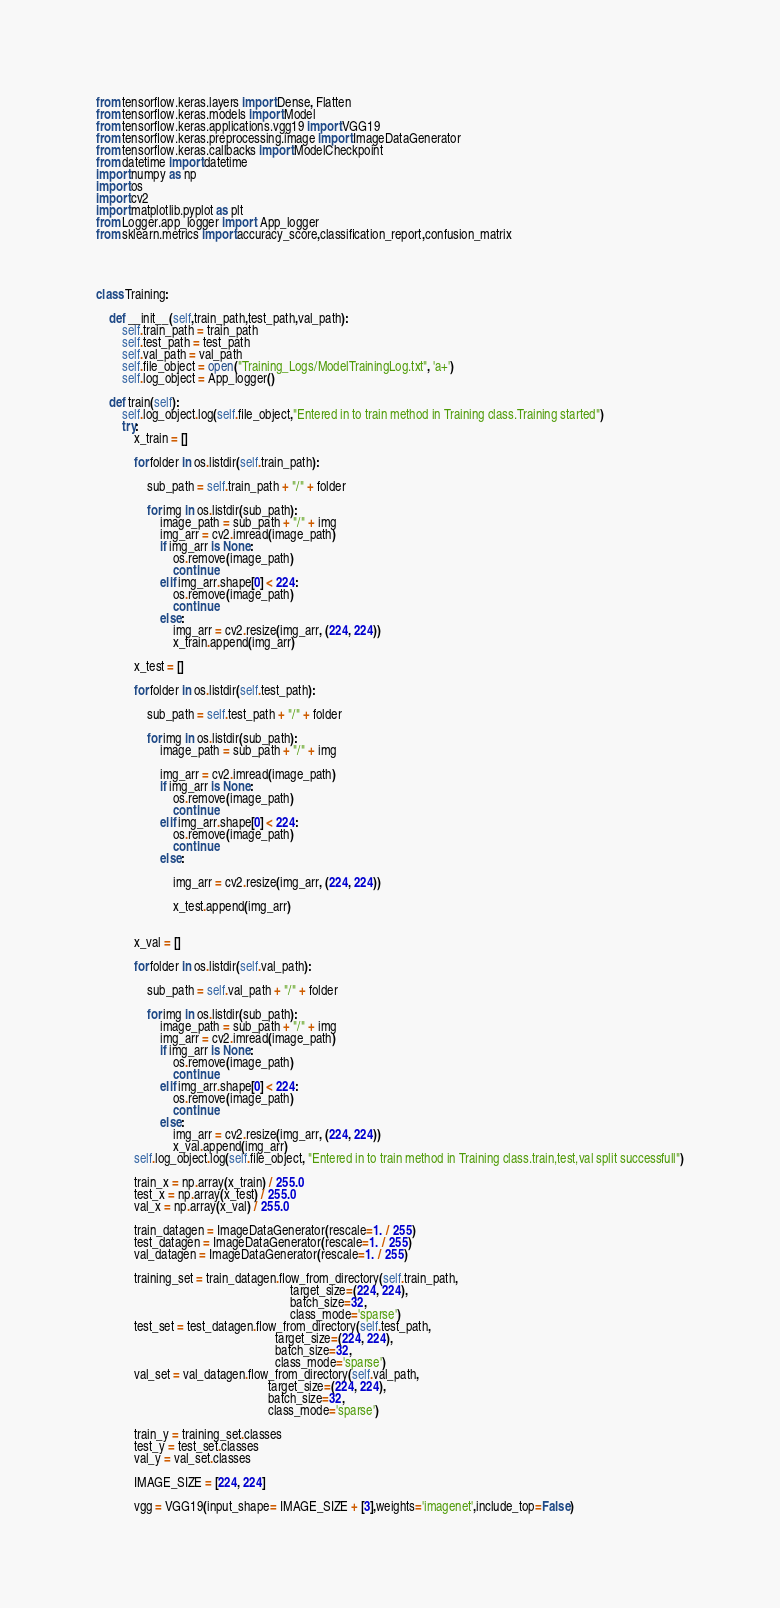Convert code to text. <code><loc_0><loc_0><loc_500><loc_500><_Python_>from tensorflow.keras.layers import Dense, Flatten
from tensorflow.keras.models import Model
from tensorflow.keras.applications.vgg19 import VGG19
from tensorflow.keras.preprocessing.image import ImageDataGenerator
from tensorflow.keras.callbacks import ModelCheckpoint
from datetime import datetime
import numpy as np
import os
import cv2
import matplotlib.pyplot as plt
from Logger.app_logger import  App_logger
from sklearn.metrics import accuracy_score,classification_report,confusion_matrix




class Training:

    def __init__(self,train_path,test_path,val_path):
        self.train_path = train_path
        self.test_path = test_path
        self.val_path = val_path
        self.file_object = open("Training_Logs/ModelTrainingLog.txt", 'a+')
        self.log_object = App_logger()

    def train(self):
        self.log_object.log(self.file_object,"Entered in to train method in Training class.Training started")
        try:
            x_train = []

            for folder in os.listdir(self.train_path):

                sub_path = self.train_path + "/" + folder

                for img in os.listdir(sub_path):
                    image_path = sub_path + "/" + img
                    img_arr = cv2.imread(image_path)
                    if img_arr is None:
                        os.remove(image_path)
                        continue
                    elif img_arr.shape[0] < 224:
                        os.remove(image_path)
                        continue
                    else:
                        img_arr = cv2.resize(img_arr, (224, 224))
                        x_train.append(img_arr)

            x_test = []

            for folder in os.listdir(self.test_path):

                sub_path = self.test_path + "/" + folder

                for img in os.listdir(sub_path):
                    image_path = sub_path + "/" + img

                    img_arr = cv2.imread(image_path)
                    if img_arr is None:
                        os.remove(image_path)
                        continue
                    elif img_arr.shape[0] < 224:
                        os.remove(image_path)
                        continue
                    else:

                        img_arr = cv2.resize(img_arr, (224, 224))

                        x_test.append(img_arr)


            x_val = []

            for folder in os.listdir(self.val_path):

                sub_path = self.val_path + "/" + folder

                for img in os.listdir(sub_path):
                    image_path = sub_path + "/" + img
                    img_arr = cv2.imread(image_path)
                    if img_arr is None:
                        os.remove(image_path)
                        continue
                    elif img_arr.shape[0] < 224:
                        os.remove(image_path)
                        continue
                    else:
                        img_arr = cv2.resize(img_arr, (224, 224))
                        x_val.append(img_arr)
            self.log_object.log(self.file_object, "Entered in to train method in Training class.train,test,val split successfull")

            train_x = np.array(x_train) / 255.0
            test_x = np.array(x_test) / 255.0
            val_x = np.array(x_val) / 255.0

            train_datagen = ImageDataGenerator(rescale=1. / 255)
            test_datagen = ImageDataGenerator(rescale=1. / 255)
            val_datagen = ImageDataGenerator(rescale=1. / 255)

            training_set = train_datagen.flow_from_directory(self.train_path,
                                                             target_size=(224, 224),
                                                             batch_size=32,
                                                             class_mode='sparse')
            test_set = test_datagen.flow_from_directory(self.test_path,
                                                        target_size=(224, 224),
                                                        batch_size=32,
                                                        class_mode='sparse')
            val_set = val_datagen.flow_from_directory(self.val_path,
                                                      target_size=(224, 224),
                                                      batch_size=32,
                                                      class_mode='sparse')

            train_y = training_set.classes
            test_y = test_set.classes
            val_y = val_set.classes

            IMAGE_SIZE = [224, 224]

            vgg = VGG19(input_shape= IMAGE_SIZE + [3],weights='imagenet',include_top=False)</code> 